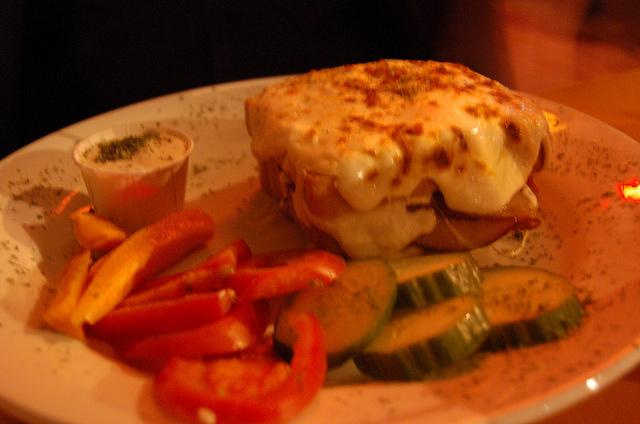What vegetable are on the plate?
Give a very brief answer. Zucchini. What is the red food?
Quick response, please. Tomatoes. Could a lactose-intolerant person enjoy this meal?
Be succinct. No. 